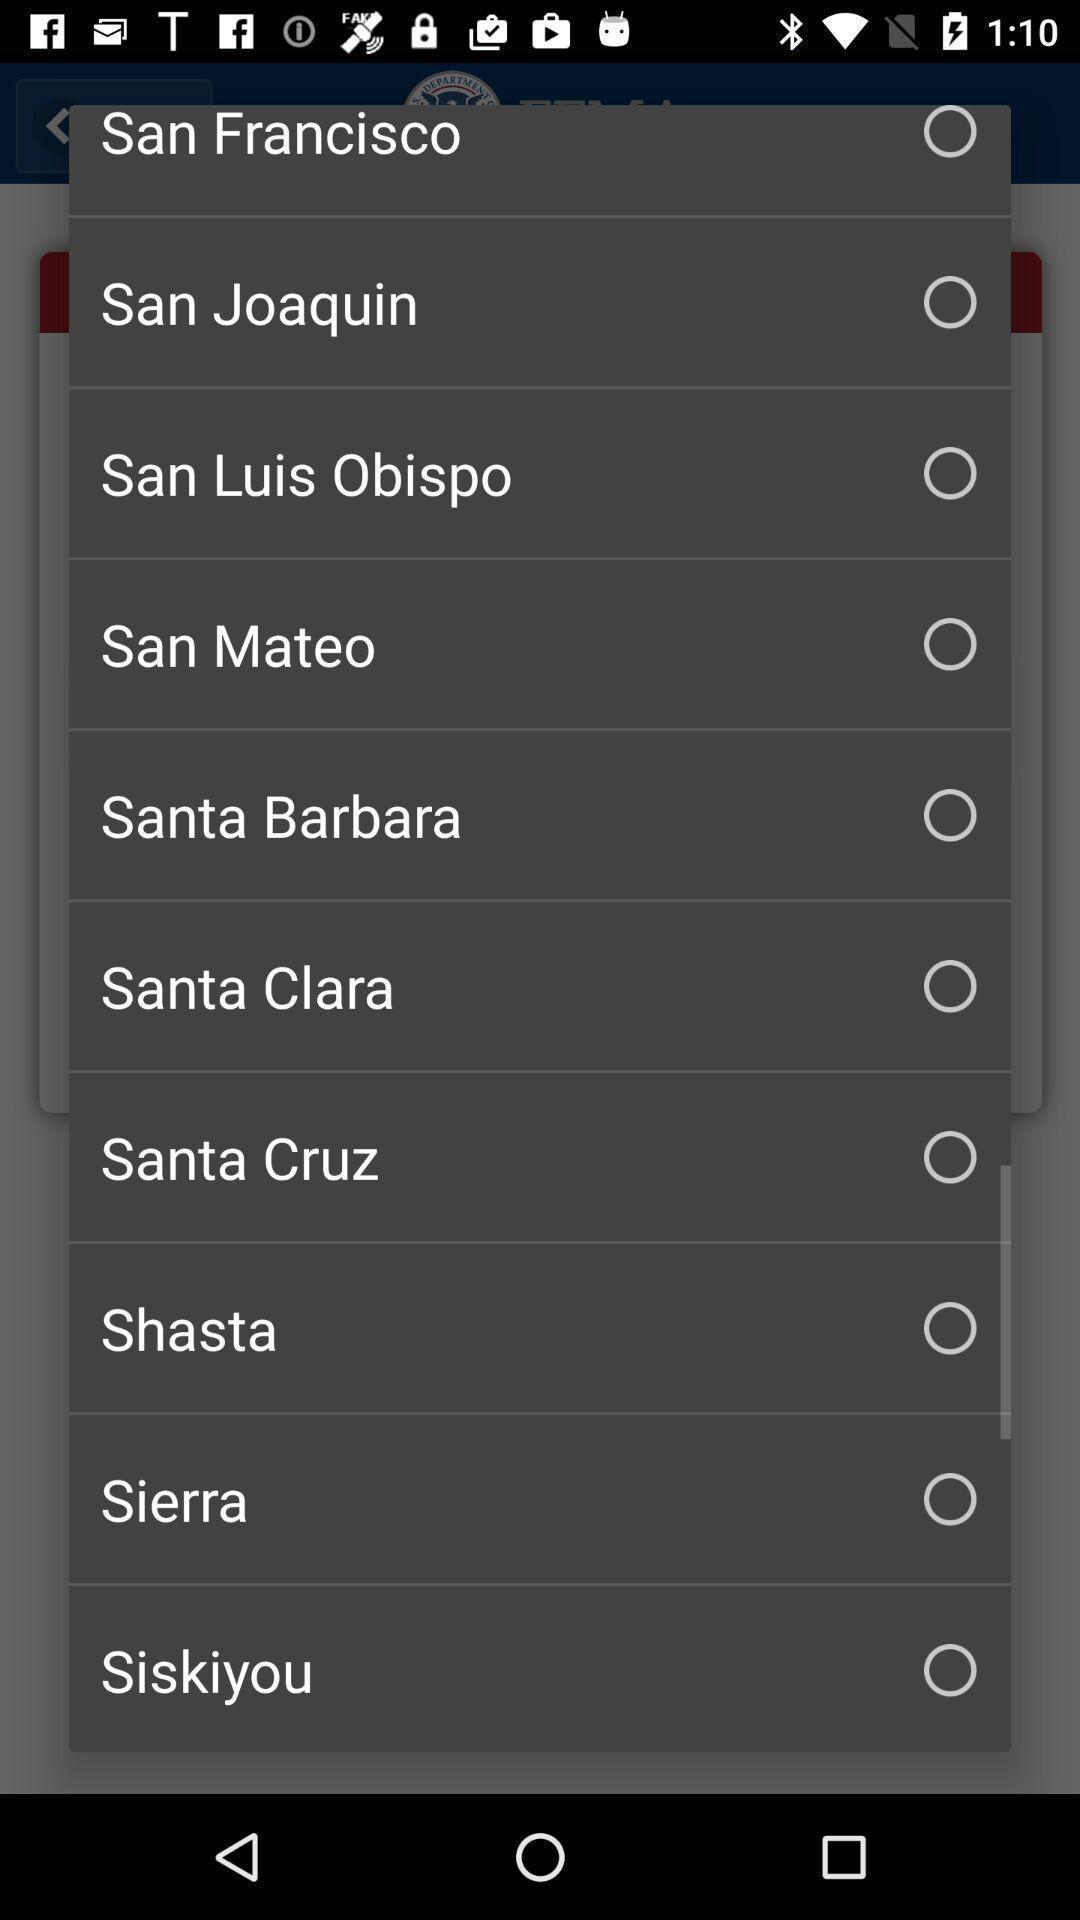Describe the content in this image. Pop-up to select the region. 